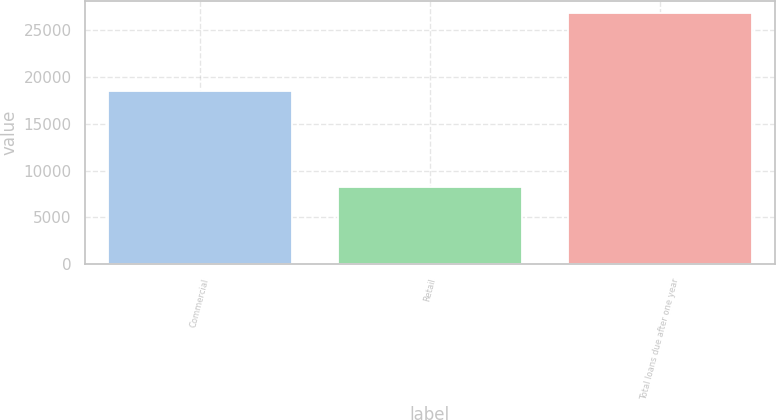Convert chart. <chart><loc_0><loc_0><loc_500><loc_500><bar_chart><fcel>Commercial<fcel>Retail<fcel>Total loans due after one year<nl><fcel>18556.1<fcel>8244.3<fcel>26800.4<nl></chart> 